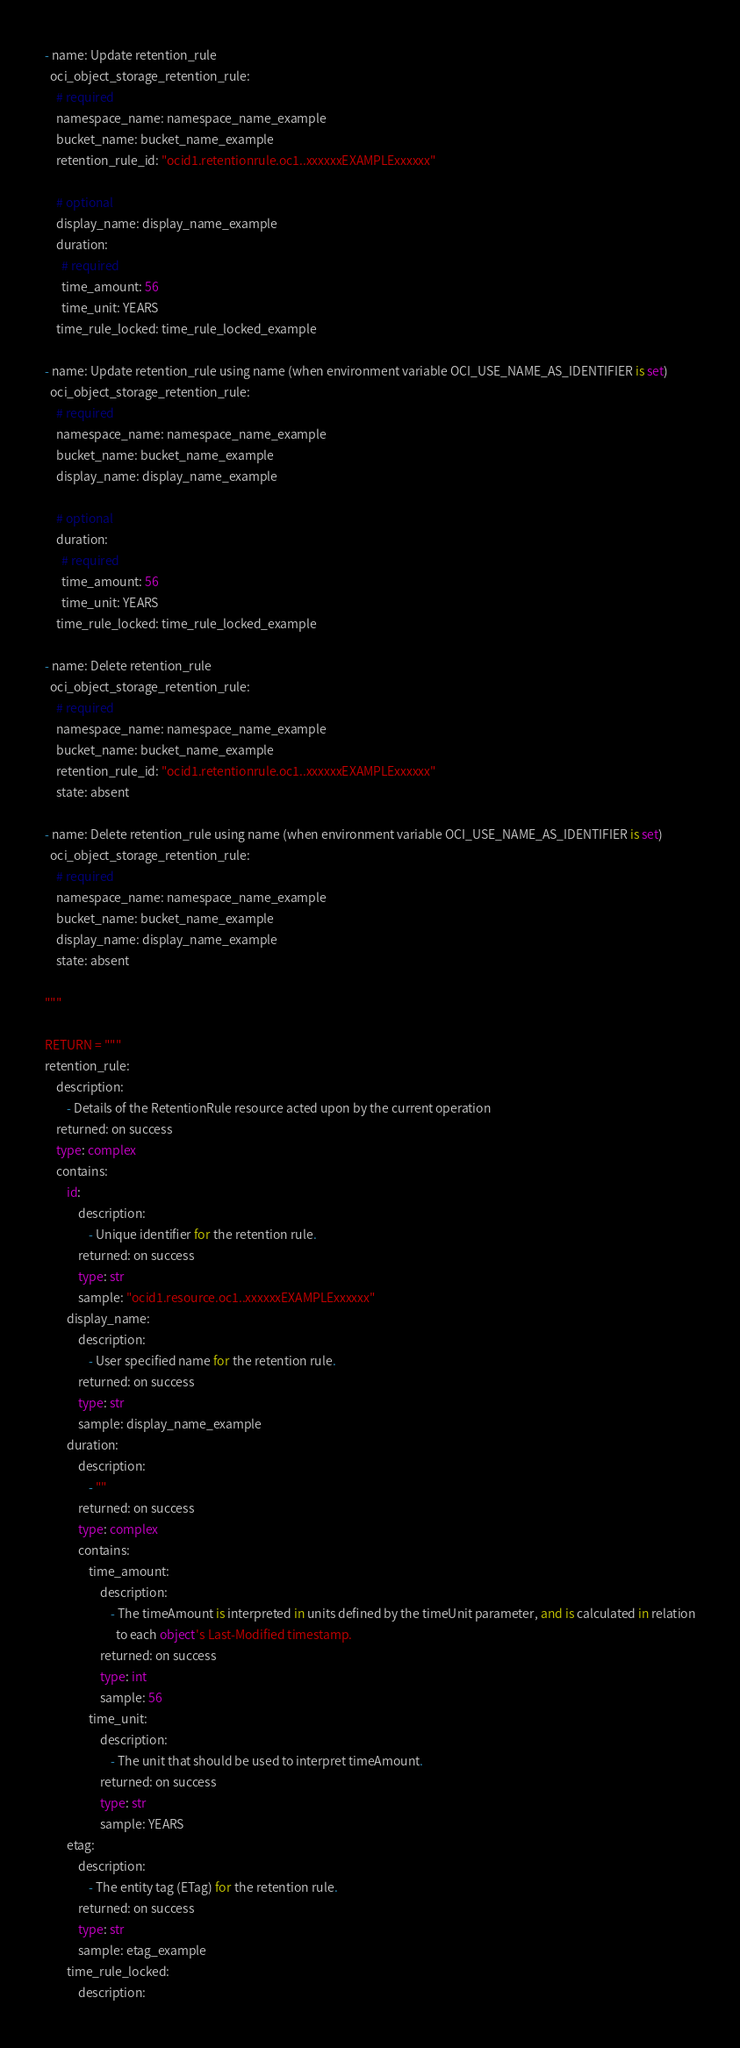Convert code to text. <code><loc_0><loc_0><loc_500><loc_500><_Python_>- name: Update retention_rule
  oci_object_storage_retention_rule:
    # required
    namespace_name: namespace_name_example
    bucket_name: bucket_name_example
    retention_rule_id: "ocid1.retentionrule.oc1..xxxxxxEXAMPLExxxxxx"

    # optional
    display_name: display_name_example
    duration:
      # required
      time_amount: 56
      time_unit: YEARS
    time_rule_locked: time_rule_locked_example

- name: Update retention_rule using name (when environment variable OCI_USE_NAME_AS_IDENTIFIER is set)
  oci_object_storage_retention_rule:
    # required
    namespace_name: namespace_name_example
    bucket_name: bucket_name_example
    display_name: display_name_example

    # optional
    duration:
      # required
      time_amount: 56
      time_unit: YEARS
    time_rule_locked: time_rule_locked_example

- name: Delete retention_rule
  oci_object_storage_retention_rule:
    # required
    namespace_name: namespace_name_example
    bucket_name: bucket_name_example
    retention_rule_id: "ocid1.retentionrule.oc1..xxxxxxEXAMPLExxxxxx"
    state: absent

- name: Delete retention_rule using name (when environment variable OCI_USE_NAME_AS_IDENTIFIER is set)
  oci_object_storage_retention_rule:
    # required
    namespace_name: namespace_name_example
    bucket_name: bucket_name_example
    display_name: display_name_example
    state: absent

"""

RETURN = """
retention_rule:
    description:
        - Details of the RetentionRule resource acted upon by the current operation
    returned: on success
    type: complex
    contains:
        id:
            description:
                - Unique identifier for the retention rule.
            returned: on success
            type: str
            sample: "ocid1.resource.oc1..xxxxxxEXAMPLExxxxxx"
        display_name:
            description:
                - User specified name for the retention rule.
            returned: on success
            type: str
            sample: display_name_example
        duration:
            description:
                - ""
            returned: on success
            type: complex
            contains:
                time_amount:
                    description:
                        - The timeAmount is interpreted in units defined by the timeUnit parameter, and is calculated in relation
                          to each object's Last-Modified timestamp.
                    returned: on success
                    type: int
                    sample: 56
                time_unit:
                    description:
                        - The unit that should be used to interpret timeAmount.
                    returned: on success
                    type: str
                    sample: YEARS
        etag:
            description:
                - The entity tag (ETag) for the retention rule.
            returned: on success
            type: str
            sample: etag_example
        time_rule_locked:
            description:</code> 